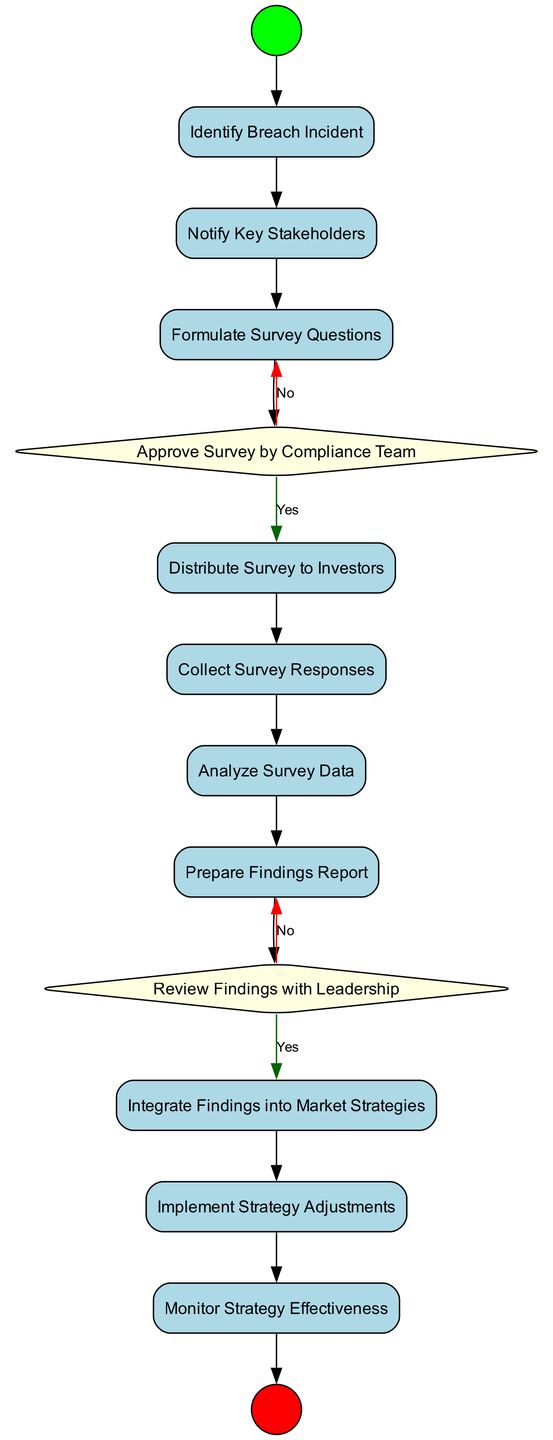What is the first activity after the start event? The first activity following the start event is "Identify Breach Incident," which is the initial step in the process as outlined in the diagram.
Answer: Identify Breach Incident How many decision points are present in the diagram? The diagram includes two decision points: one for "Approve Survey by Compliance Team" and another for "Review Findings with Leadership." Therefore, the total count of decision points is two.
Answer: 2 What is the activity that follows "Distribute Survey to Investors"? The activity directly following "Distribute Survey to Investors" is "Collect Survey Responses," which logically continues the process of gathering investor input after the survey is distributed.
Answer: Collect Survey Responses What color represents the end event in the diagram? The end event in the diagram is represented by the color red, indicating the conclusion of the process when all necessary steps have been completed.
Answer: Red Which activity comes after "Analyze Survey Data"? The activity that comes next after "Analyze Survey Data" is "Prepare Findings Report," which denotes the step where the results from the survey analysis are documented.
Answer: Prepare Findings Report If the compliance team does not approve the survey, what is the next step? If the compliance team does not approve the survey, the flow indicates a "No" outcome, which suggests that the process would revert to earlier stages to possibly revise or revisit the survey questions.
Answer: Revisit Survey Questions 